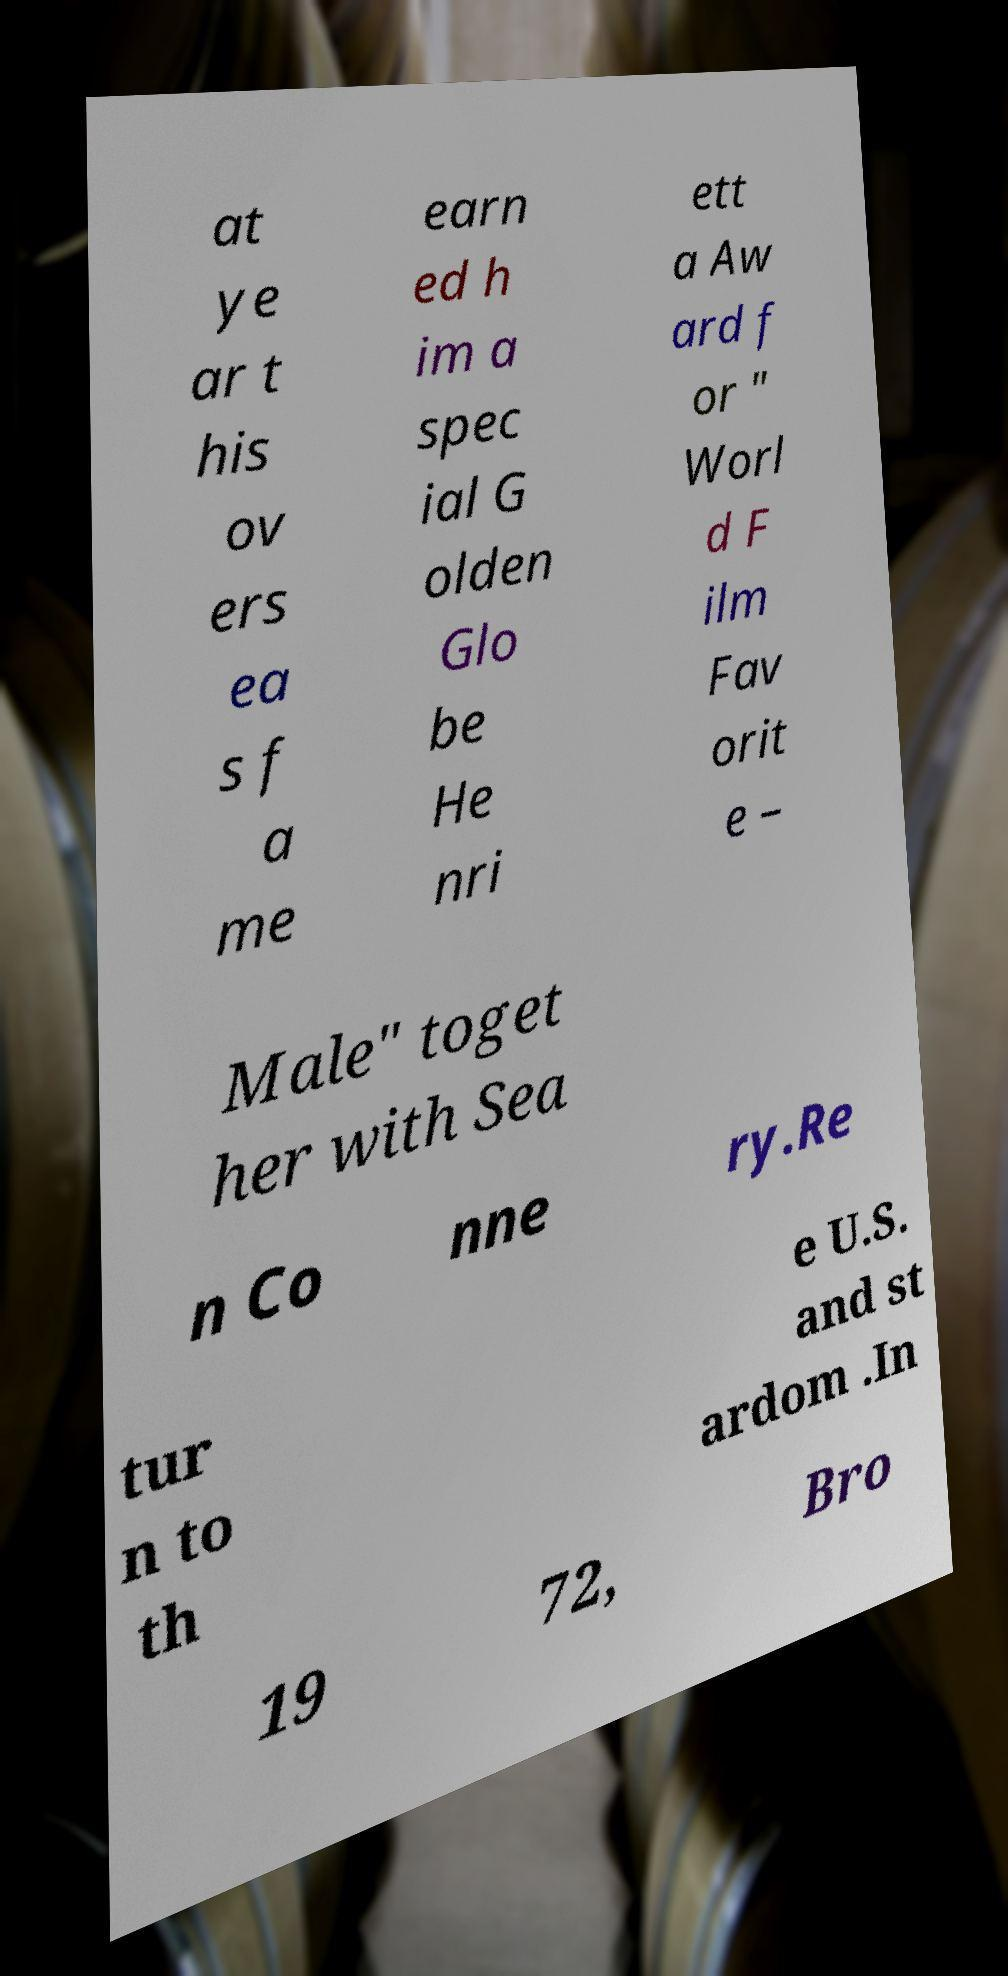I need the written content from this picture converted into text. Can you do that? at ye ar t his ov ers ea s f a me earn ed h im a spec ial G olden Glo be He nri ett a Aw ard f or " Worl d F ilm Fav orit e – Male" toget her with Sea n Co nne ry.Re tur n to th e U.S. and st ardom .In 19 72, Bro 